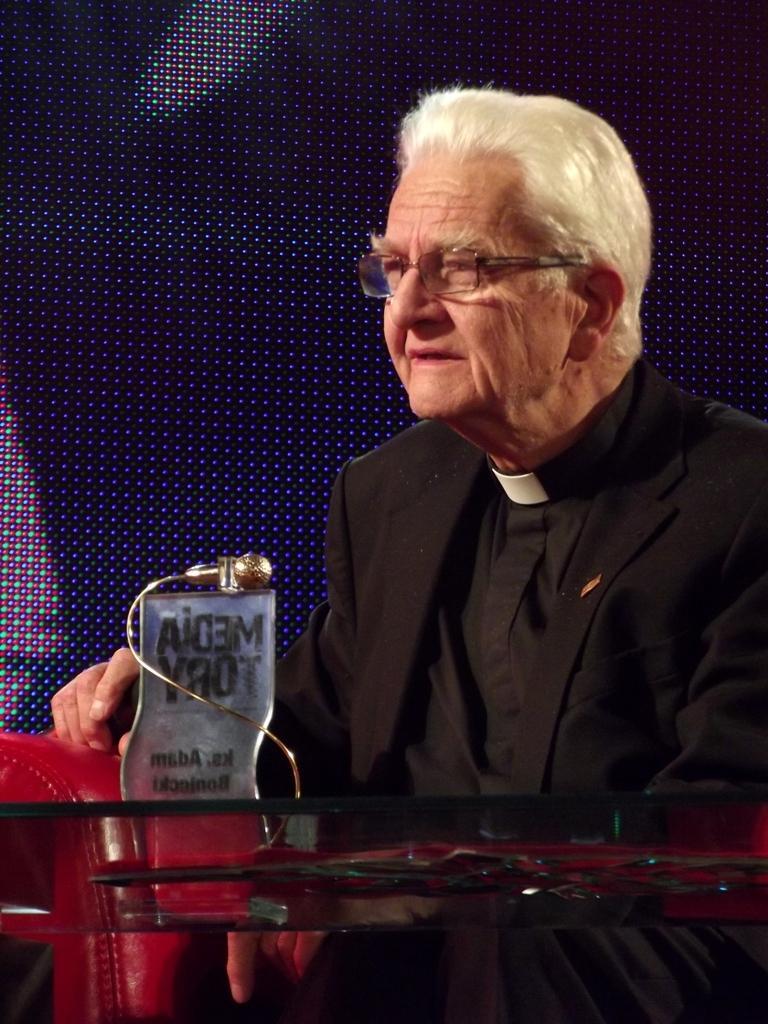Can you describe this image briefly? In this picture I can see a man in front who is sitting on a sofa chair, which is of red color and I can see a glass table in front of him and I see a thing on it and I see something is written. 